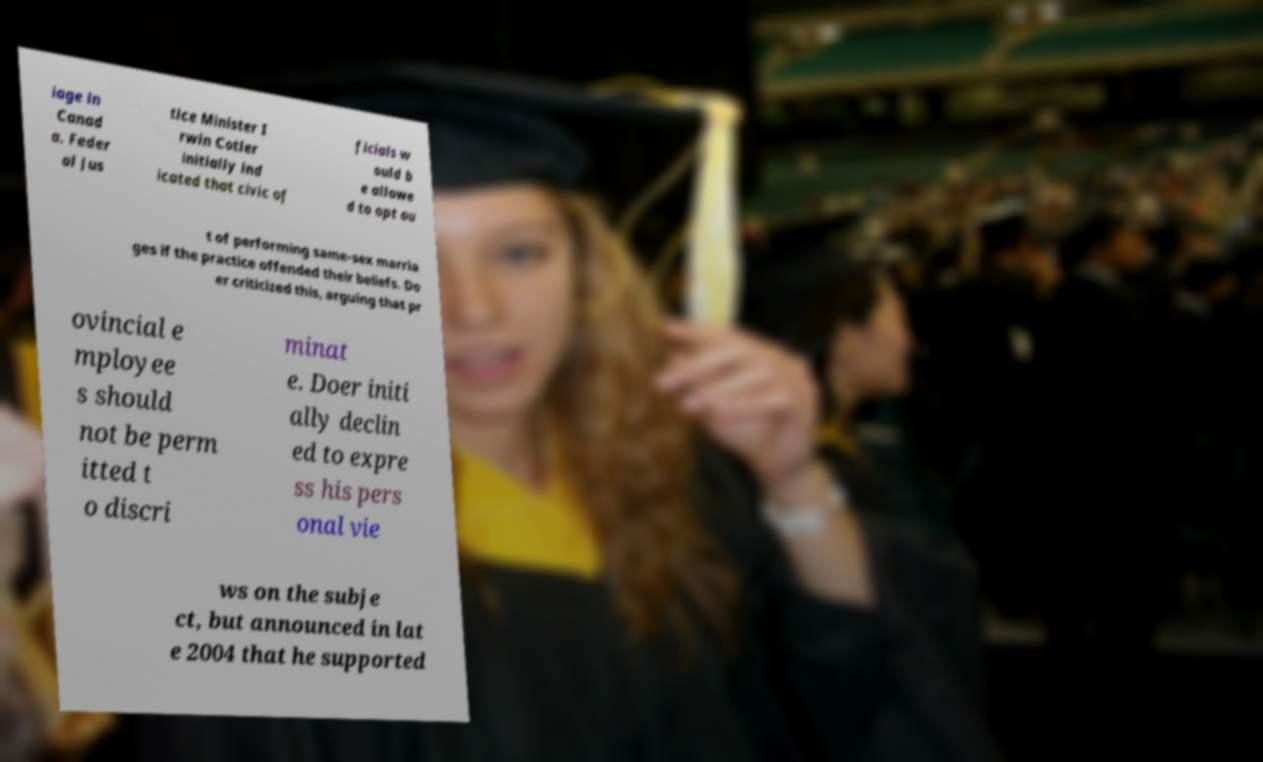Can you read and provide the text displayed in the image?This photo seems to have some interesting text. Can you extract and type it out for me? iage in Canad a. Feder al Jus tice Minister I rwin Cotler initially ind icated that civic of ficials w ould b e allowe d to opt ou t of performing same-sex marria ges if the practice offended their beliefs. Do er criticized this, arguing that pr ovincial e mployee s should not be perm itted t o discri minat e. Doer initi ally declin ed to expre ss his pers onal vie ws on the subje ct, but announced in lat e 2004 that he supported 